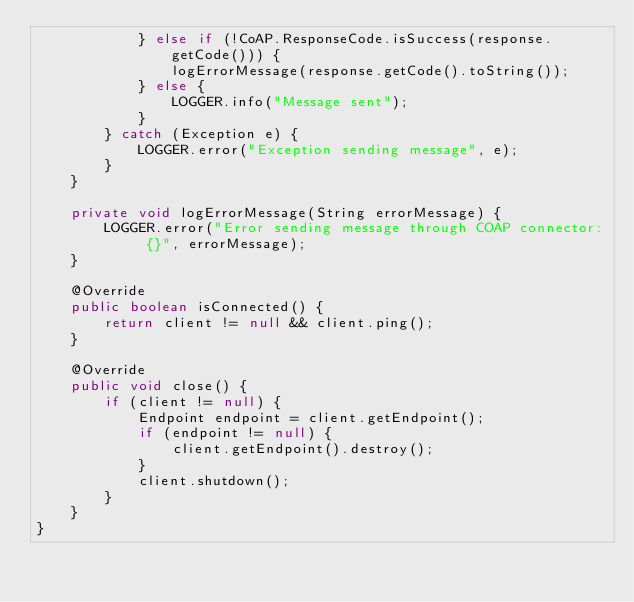<code> <loc_0><loc_0><loc_500><loc_500><_Java_>            } else if (!CoAP.ResponseCode.isSuccess(response.getCode())) {
                logErrorMessage(response.getCode().toString());
            } else {
                LOGGER.info("Message sent");
            }
        } catch (Exception e) {
            LOGGER.error("Exception sending message", e);
        }
    }

    private void logErrorMessage(String errorMessage) {
        LOGGER.error("Error sending message through COAP connector: {}", errorMessage);
    }

    @Override
    public boolean isConnected() {
        return client != null && client.ping();
    }

    @Override
    public void close() {
        if (client != null) {
            Endpoint endpoint = client.getEndpoint();
            if (endpoint != null) {
                client.getEndpoint().destroy();
            }
            client.shutdown();
        }
    }
}
</code> 